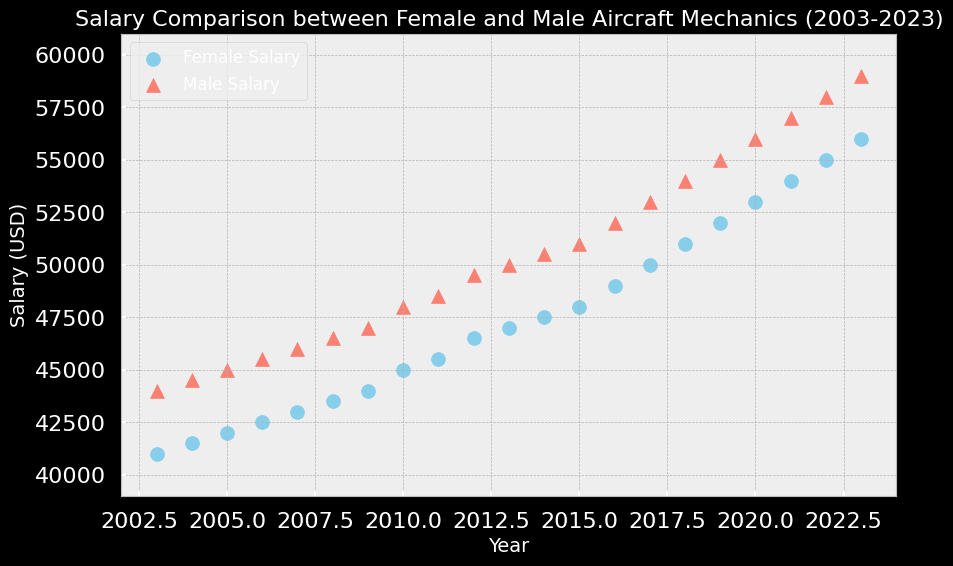What is the difference in salary between male and female aircraft mechanics in 2023? To find the difference in salary, look at the data points for 2023 from both the male and female salaries. The salaries are $59,000 for males and $56,000 for females. Subtract the female salary from the male salary: $59,000 - $56,000 = $3,000.
Answer: $3,000 Which year shows the smallest salary gap between male and female aircraft mechanics? To identify the year with the smallest salary gap, calculate the difference between male and female salaries for each year and find the smallest value. The smallest gap is in 2023: $59,000 - $56,000 = $3,000.
Answer: 2023 How has the salary gap between male and female aircraft mechanics changed over the 20-year period? Examine the salary differences between males and females from 2003 to 2023. The gap in 2003 is $44,000 - $41,000 = $3,000, whereas in 2023, the gap is $59,000 - $56,000 = $3,000. The gap has remained constant at $3,000 over the 20 years.
Answer: Constant In which year did female aircraft mechanics first earn $50,000 or more? Look at the data points for female salaries from the earliest year. Female salaries first reach $50,000 in 2017.
Answer: 2017 What is the average salary of male aircraft mechanics over the 20-year period? To find the average, sum all male salaries from 2003 to 2023 and divide by the number of years. Total sum = ($44,000 + $44,500 + $45,000 + ... + $57,000 + $58,000 + $59,000) = $1,060,000, divided by 21 years. $1,060,000 / 21 = approximately $50,476.19.
Answer: $50,476.19 How does the salary increase for female aircraft mechanics from 2003 to 2023 compare to that for male aircraft mechanics? Calculate the salary increase for both groups: Female salary increase = $56,000 (2023) - $41,000 (2003) = $15,000, and Male salary increase = $59,000 (2023) - $44,000 (2003) = $15,000. Both have an increase of $15,000 over the period.
Answer: Equal In what year did male and female aircraft mechanics have the exact same salary increase from the previous year? Look at the year-over-year salary changes for both genders. In 2009, the increase is $1,000 for both male and female salaries (Male: $46,500 to $47,000, Female: $43,500 to $44,000).
Answer: 2009 What has been the trend of salary changes for female aircraft mechanics over the 20 years? Observing the data points, we can see a consistent upward trend in female salaries from $41,000 in 2003 to $56,000 in 2023, indicating steady yearly increases.
Answer: Upward trend Which year shows the highest difference between male and female aircraft mechanics' salaries? Calculate the difference for each year and find the highest value. The highest difference is in 2022: $58,000 - $55,000 = $3,000.
Answer: 2022 